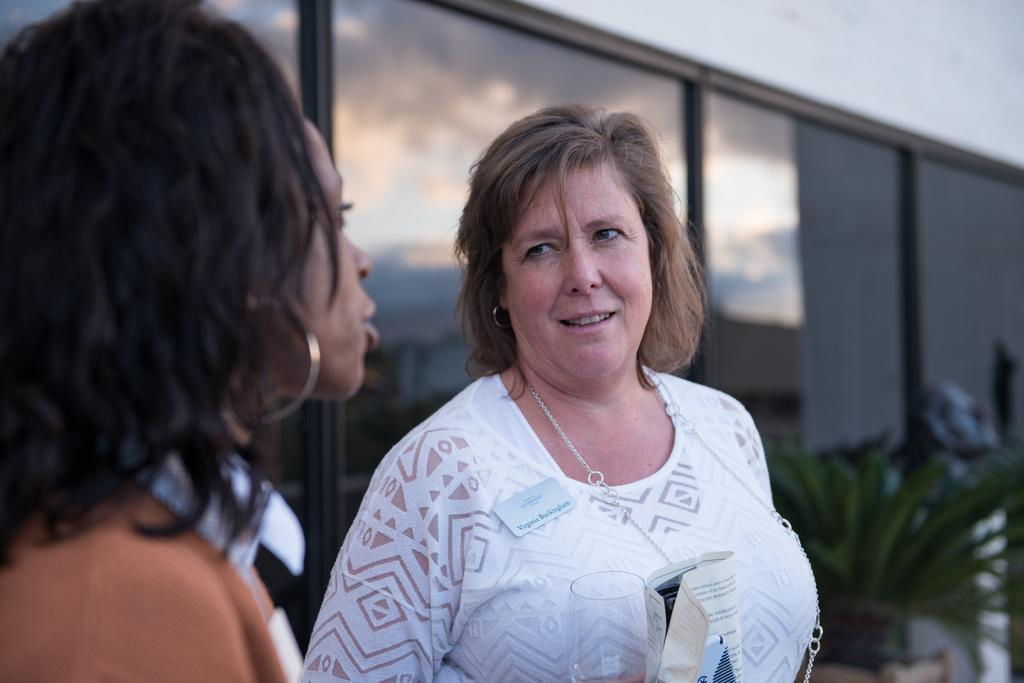How many women are in the image? There are two women in the image. What are the women holding in their hands? One of the women is holding a glass, and the other is holding a paper. What can be seen in the background of the image? There are glass windows and a plant in the background of the image. What type of mark can be seen on the receipt in the image? There is no receipt present in the image, so it is not possible to determine if there is a mark on it. 